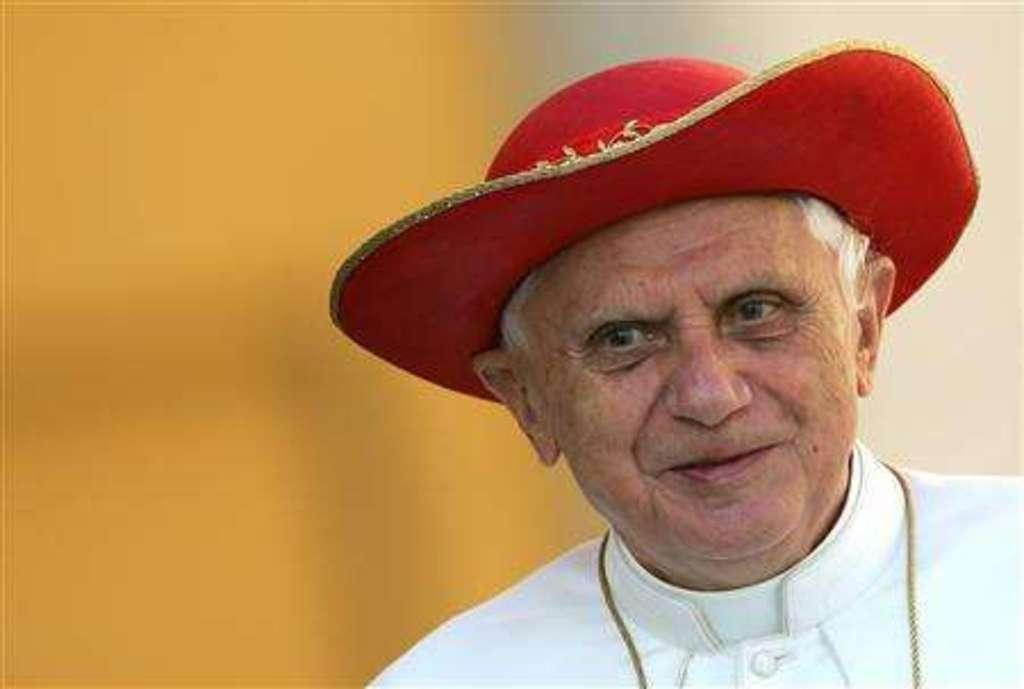Who is present in the image? There is a man in the picture. What is the man wearing on his upper body? The man is wearing a white dress. What type of headwear is the man wearing? The man is wearing a red hat. Can you describe the background of the image? The background of the image is blurred. What type of debt is the man discussing in the image? There is no indication in the image that the man is discussing any type of debt, as the focus is on his clothing and the blurred background. 